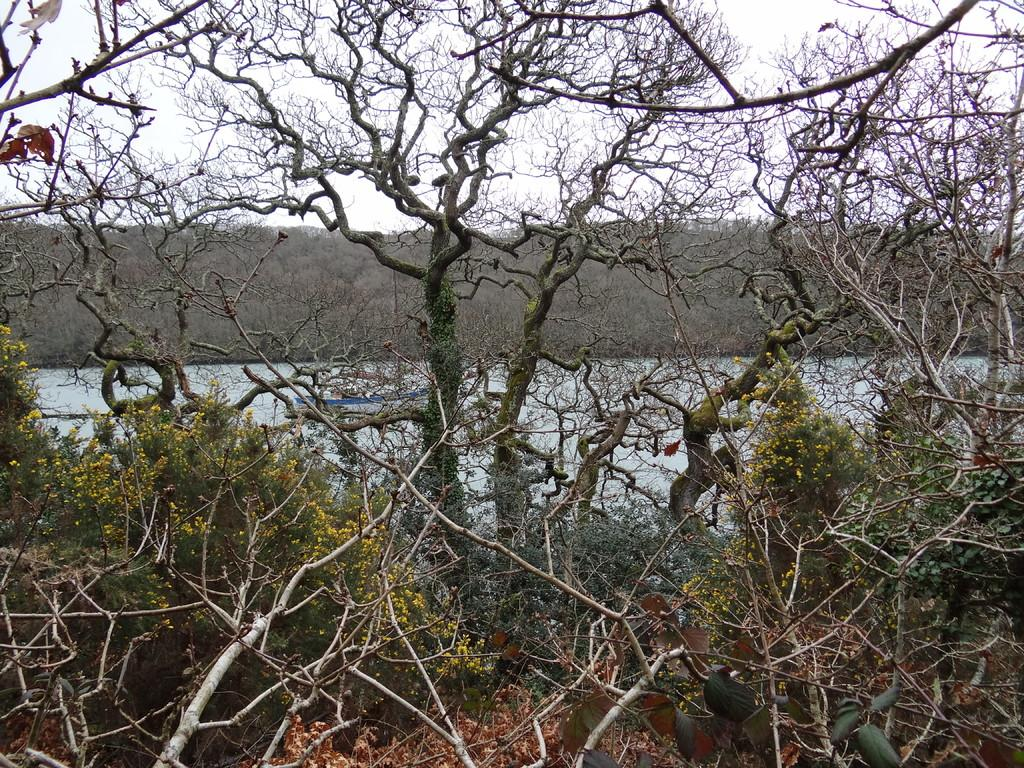What is the setting of the image? The image has an outside view. What can be seen in the foreground of the image? There are trees in the foreground. What is the location of the trees in relation to the lake? The trees are beside a lake. What is visible in the background of the image? There is a hill and the sky in the background. What type of operation is being performed on the friend in the image? There is no operation or friend present in the image; it features an outdoor scene with trees, a lake, a hill, and the sky. 